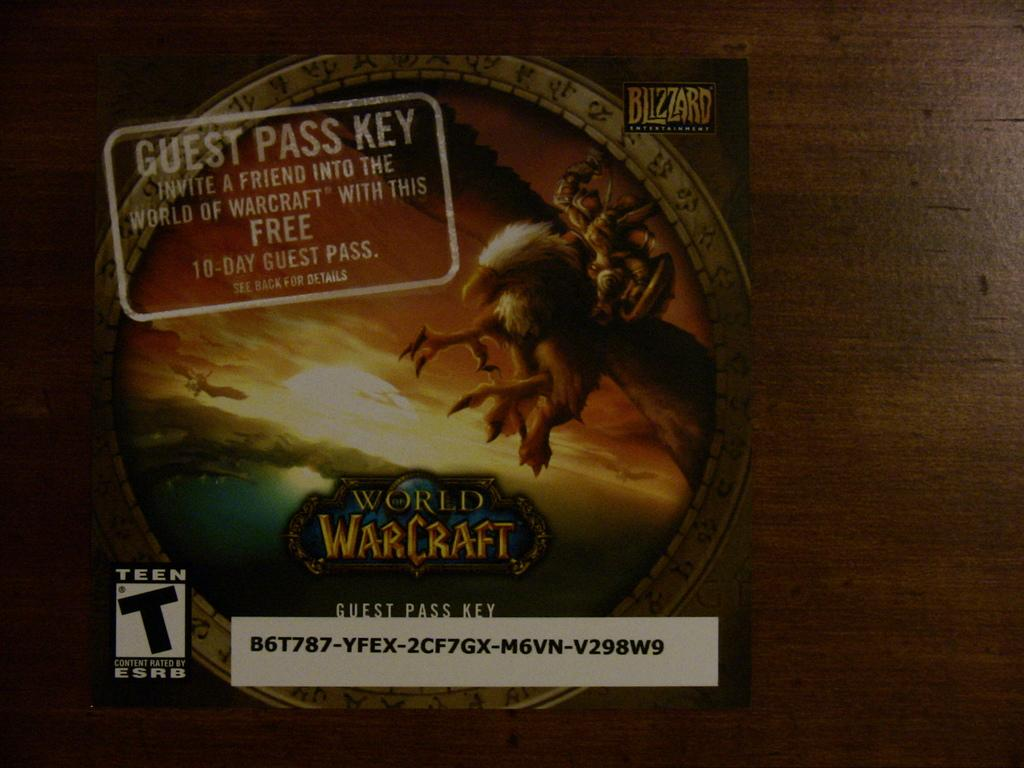What is present in the image that contains information or identification? There is a label in the image. What type of image is featured on the label? The label contains an animated image. Are there any words or letters on the label? Yes, the label includes text. What type of animals can be seen at the zoo in the image? There is no zoo present in the image; it features a label with an animated image and text. What type of fuel is being used for the operation in the image? There is no operation or fuel mentioned in the image; it only contains a label with an animated image and text. 